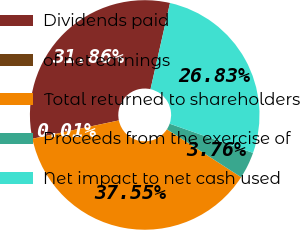Convert chart to OTSL. <chart><loc_0><loc_0><loc_500><loc_500><pie_chart><fcel>Dividends paid<fcel>of net earnings<fcel>Total returned to shareholders<fcel>Proceeds from the exercise of<fcel>Net impact to net cash used<nl><fcel>31.86%<fcel>0.01%<fcel>37.55%<fcel>3.76%<fcel>26.83%<nl></chart> 